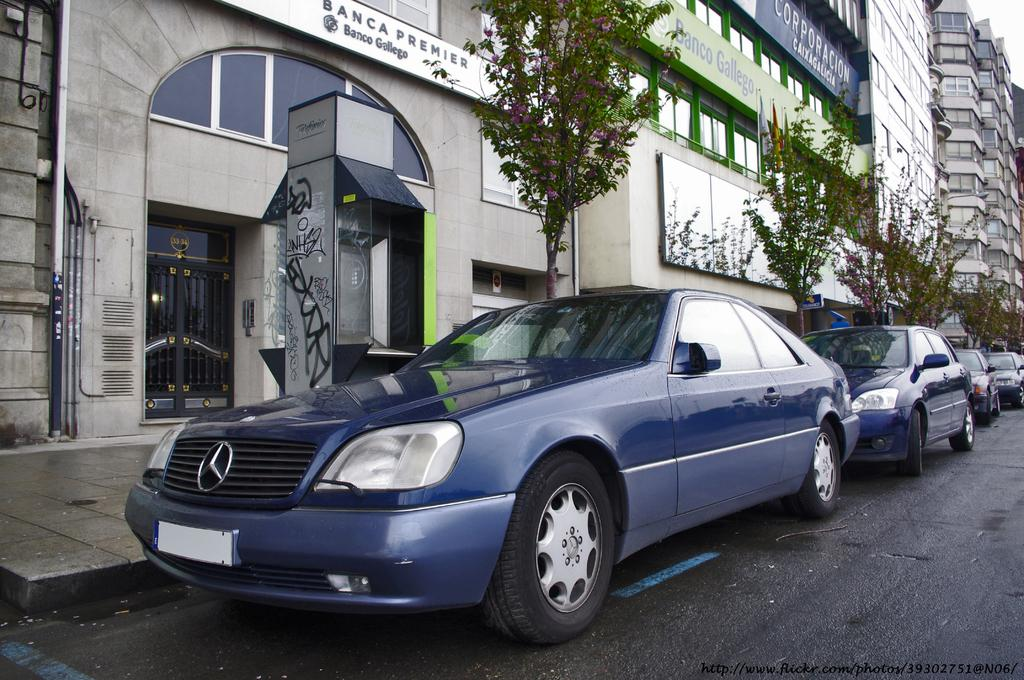What can be seen on the road in the image? There are cars on the road in the image. What type of vegetation is present in the image? There are trees in the image. What type of structures can be seen in the image? There are buildings with windows in the image. What type of signage is present in the image? Name boards are present in the image. What type of access points are visible in the image? Doors are visible in the image. What type of path is present for pedestrians in the image? There is a footpath in the image. What type of equipment is present in the image? A machine is present in the image. What other objects can be seen in the image? There are other objects in the image. What type of pen is being used to write on the cars in the image? There is no pen present in the image. --- Facts: 1. There is a person in the image. 2. The person is wearing a hat. 3. The person is holding a book. 4. The person is sitting on a chair. 5. There is a table in the image. 6. There is a lamp on the table. 7. There is a window in the image. 8. There is a painting on the wall. Absurd Topics: elephant, piano, surgery Conversation: What can be seen in the image? There is a person in the image. What is the person wearing? The person is wearing a hat. What is the person holding? The person is holding a book. What is the person sitting on? The person is sitting on a chair. What is present on the table? There is a lamp on the table. What can be seen through the window? There is a window in the image. What is present on the wall? There is a painting on the wall. Reasoning: Let's think step by step in order to produce the conversation. We start by identifying the main subject of the image, which is the person. Then, we describe specific features of the person, such as the hat and the book they are holding. Next, we observe the actions of the person, noting that they are sitting on a chair. Then, we describe the objects present in the image, such as the table, the lamp, the window, and the painting. Finally, we formulate questions that focus on the location and characteristics of these subjects and objects, ensuring that each question can be answered definitively with the information given. We avoid yes/no questions and ensure that the language is simple and clear. Absurd Question/Answer: What type of elephant can be seen playing the piano in the image? There is no elephant present in the image, let alone one playing the piano. --- Facts: 1. There is a group of people in the 